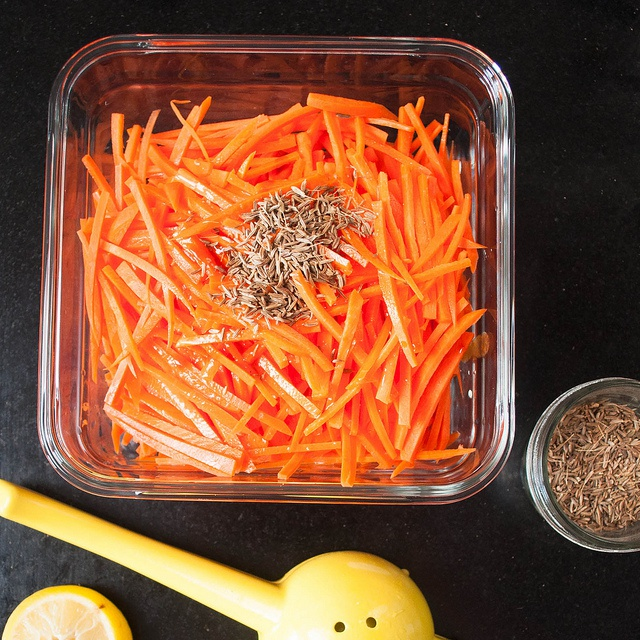Describe the objects in this image and their specific colors. I can see bowl in black, red, maroon, and orange tones, carrot in black, red, and orange tones, dining table in black, gray, and maroon tones, spoon in black, gold, khaki, lightyellow, and orange tones, and bowl in black, gray, and maroon tones in this image. 